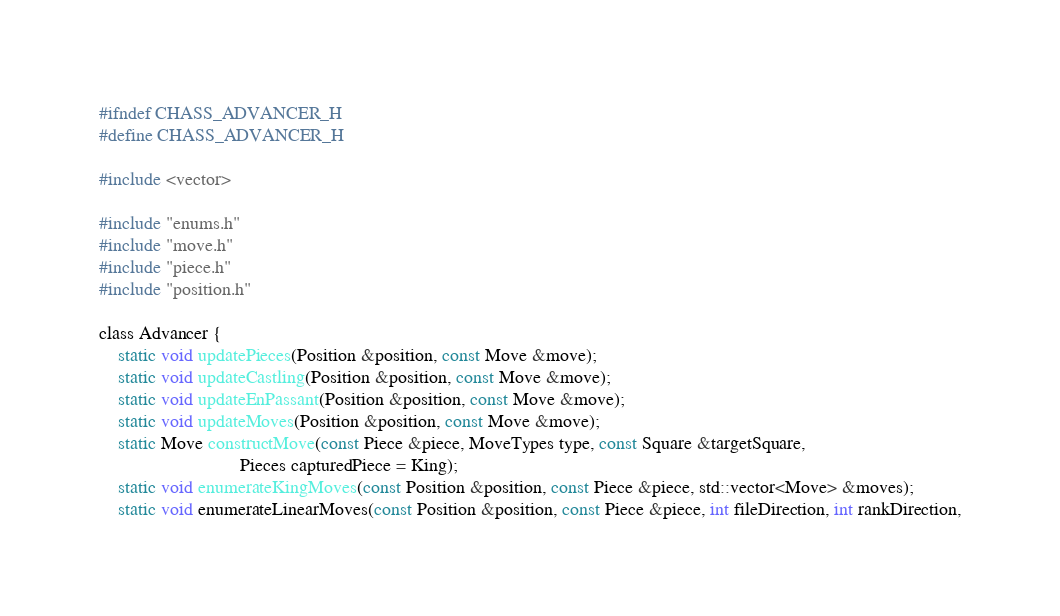<code> <loc_0><loc_0><loc_500><loc_500><_C_>#ifndef CHASS_ADVANCER_H
#define CHASS_ADVANCER_H

#include <vector>

#include "enums.h"
#include "move.h"
#include "piece.h"
#include "position.h"

class Advancer {
    static void updatePieces(Position &position, const Move &move);
    static void updateCastling(Position &position, const Move &move);
    static void updateEnPassant(Position &position, const Move &move);
    static void updateMoves(Position &position, const Move &move);
    static Move constructMove(const Piece &piece, MoveTypes type, const Square &targetSquare,
                              Pieces capturedPiece = King);
    static void enumerateKingMoves(const Position &position, const Piece &piece, std::vector<Move> &moves);
    static void enumerateLinearMoves(const Position &position, const Piece &piece, int fileDirection, int rankDirection,</code> 